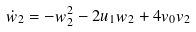<formula> <loc_0><loc_0><loc_500><loc_500>\dot { w } _ { 2 } = - w _ { 2 } ^ { 2 } - 2 u _ { 1 } w _ { 2 } + 4 v _ { 0 } v _ { 2 }</formula> 